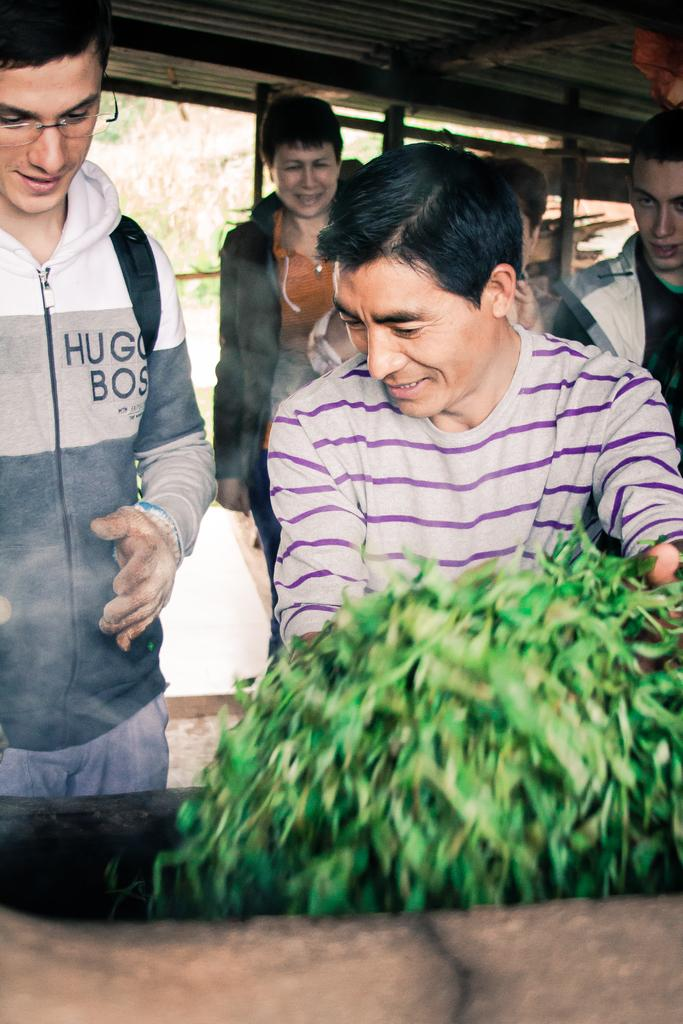How many people are in the image? There is a group of people in the image. What are the people doing in the image? The people are standing on the ground and smiling. What type of vegetation is present in the image? There is a plant in the image. What architectural features can be seen in the background of the image? There are pillars visible in the background of the image. What type of record can be seen spinning on a turntable in the image? There is no record or turntable present in the image. 